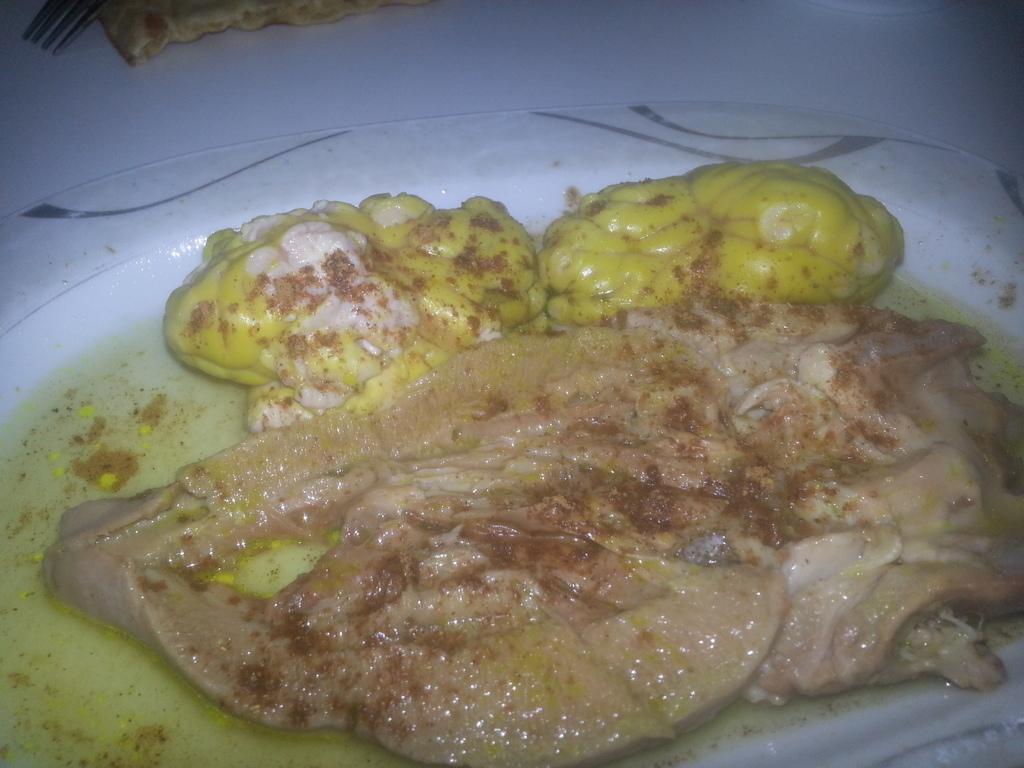How would you summarize this image in a sentence or two? In this image we can see food in plate placed on the table. 